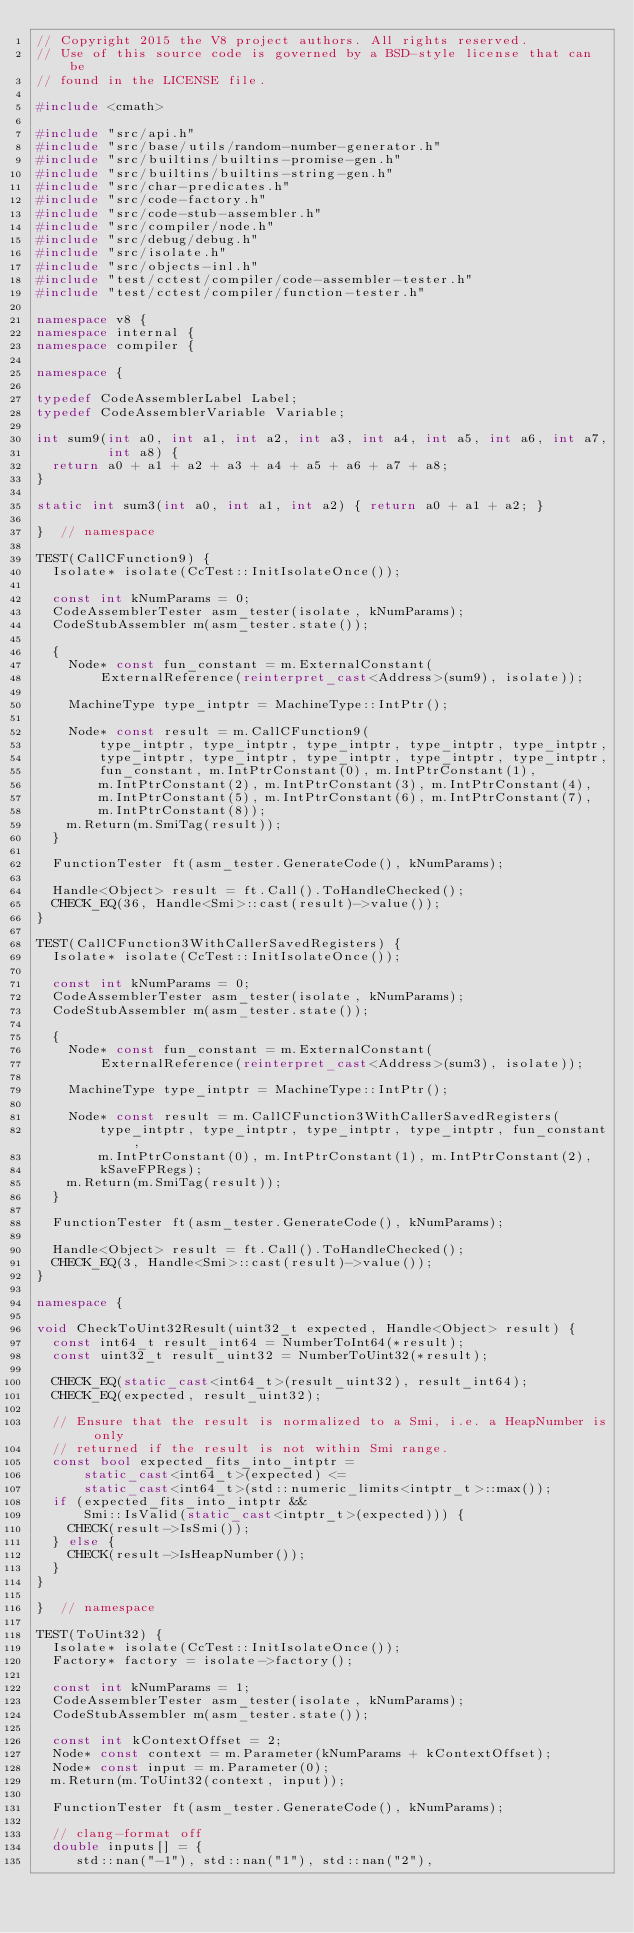Convert code to text. <code><loc_0><loc_0><loc_500><loc_500><_C++_>// Copyright 2015 the V8 project authors. All rights reserved.
// Use of this source code is governed by a BSD-style license that can be
// found in the LICENSE file.

#include <cmath>

#include "src/api.h"
#include "src/base/utils/random-number-generator.h"
#include "src/builtins/builtins-promise-gen.h"
#include "src/builtins/builtins-string-gen.h"
#include "src/char-predicates.h"
#include "src/code-factory.h"
#include "src/code-stub-assembler.h"
#include "src/compiler/node.h"
#include "src/debug/debug.h"
#include "src/isolate.h"
#include "src/objects-inl.h"
#include "test/cctest/compiler/code-assembler-tester.h"
#include "test/cctest/compiler/function-tester.h"

namespace v8 {
namespace internal {
namespace compiler {

namespace {

typedef CodeAssemblerLabel Label;
typedef CodeAssemblerVariable Variable;

int sum9(int a0, int a1, int a2, int a3, int a4, int a5, int a6, int a7,
         int a8) {
  return a0 + a1 + a2 + a3 + a4 + a5 + a6 + a7 + a8;
}

static int sum3(int a0, int a1, int a2) { return a0 + a1 + a2; }

}  // namespace

TEST(CallCFunction9) {
  Isolate* isolate(CcTest::InitIsolateOnce());

  const int kNumParams = 0;
  CodeAssemblerTester asm_tester(isolate, kNumParams);
  CodeStubAssembler m(asm_tester.state());

  {
    Node* const fun_constant = m.ExternalConstant(
        ExternalReference(reinterpret_cast<Address>(sum9), isolate));

    MachineType type_intptr = MachineType::IntPtr();

    Node* const result = m.CallCFunction9(
        type_intptr, type_intptr, type_intptr, type_intptr, type_intptr,
        type_intptr, type_intptr, type_intptr, type_intptr, type_intptr,
        fun_constant, m.IntPtrConstant(0), m.IntPtrConstant(1),
        m.IntPtrConstant(2), m.IntPtrConstant(3), m.IntPtrConstant(4),
        m.IntPtrConstant(5), m.IntPtrConstant(6), m.IntPtrConstant(7),
        m.IntPtrConstant(8));
    m.Return(m.SmiTag(result));
  }

  FunctionTester ft(asm_tester.GenerateCode(), kNumParams);

  Handle<Object> result = ft.Call().ToHandleChecked();
  CHECK_EQ(36, Handle<Smi>::cast(result)->value());
}

TEST(CallCFunction3WithCallerSavedRegisters) {
  Isolate* isolate(CcTest::InitIsolateOnce());

  const int kNumParams = 0;
  CodeAssemblerTester asm_tester(isolate, kNumParams);
  CodeStubAssembler m(asm_tester.state());

  {
    Node* const fun_constant = m.ExternalConstant(
        ExternalReference(reinterpret_cast<Address>(sum3), isolate));

    MachineType type_intptr = MachineType::IntPtr();

    Node* const result = m.CallCFunction3WithCallerSavedRegisters(
        type_intptr, type_intptr, type_intptr, type_intptr, fun_constant,
        m.IntPtrConstant(0), m.IntPtrConstant(1), m.IntPtrConstant(2),
        kSaveFPRegs);
    m.Return(m.SmiTag(result));
  }

  FunctionTester ft(asm_tester.GenerateCode(), kNumParams);

  Handle<Object> result = ft.Call().ToHandleChecked();
  CHECK_EQ(3, Handle<Smi>::cast(result)->value());
}

namespace {

void CheckToUint32Result(uint32_t expected, Handle<Object> result) {
  const int64_t result_int64 = NumberToInt64(*result);
  const uint32_t result_uint32 = NumberToUint32(*result);

  CHECK_EQ(static_cast<int64_t>(result_uint32), result_int64);
  CHECK_EQ(expected, result_uint32);

  // Ensure that the result is normalized to a Smi, i.e. a HeapNumber is only
  // returned if the result is not within Smi range.
  const bool expected_fits_into_intptr =
      static_cast<int64_t>(expected) <=
      static_cast<int64_t>(std::numeric_limits<intptr_t>::max());
  if (expected_fits_into_intptr &&
      Smi::IsValid(static_cast<intptr_t>(expected))) {
    CHECK(result->IsSmi());
  } else {
    CHECK(result->IsHeapNumber());
  }
}

}  // namespace

TEST(ToUint32) {
  Isolate* isolate(CcTest::InitIsolateOnce());
  Factory* factory = isolate->factory();

  const int kNumParams = 1;
  CodeAssemblerTester asm_tester(isolate, kNumParams);
  CodeStubAssembler m(asm_tester.state());

  const int kContextOffset = 2;
  Node* const context = m.Parameter(kNumParams + kContextOffset);
  Node* const input = m.Parameter(0);
  m.Return(m.ToUint32(context, input));

  FunctionTester ft(asm_tester.GenerateCode(), kNumParams);

  // clang-format off
  double inputs[] = {
     std::nan("-1"), std::nan("1"), std::nan("2"),</code> 